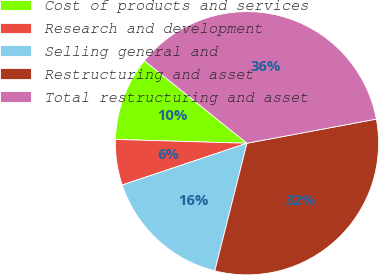<chart> <loc_0><loc_0><loc_500><loc_500><pie_chart><fcel>Cost of products and services<fcel>Research and development<fcel>Selling general and<fcel>Restructuring and asset<fcel>Total restructuring and asset<nl><fcel>10.32%<fcel>5.6%<fcel>15.93%<fcel>31.86%<fcel>36.28%<nl></chart> 